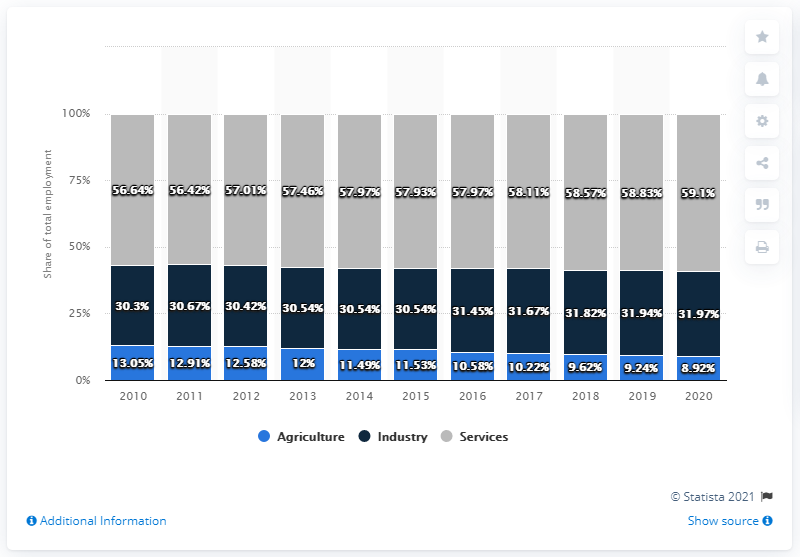Point out several critical features in this image. The employment distribution in 2010 was divided among the agriculture, industry, and services sectors, with the exact sum being 99.99.. The highest blue bar has a value of 13.05. 